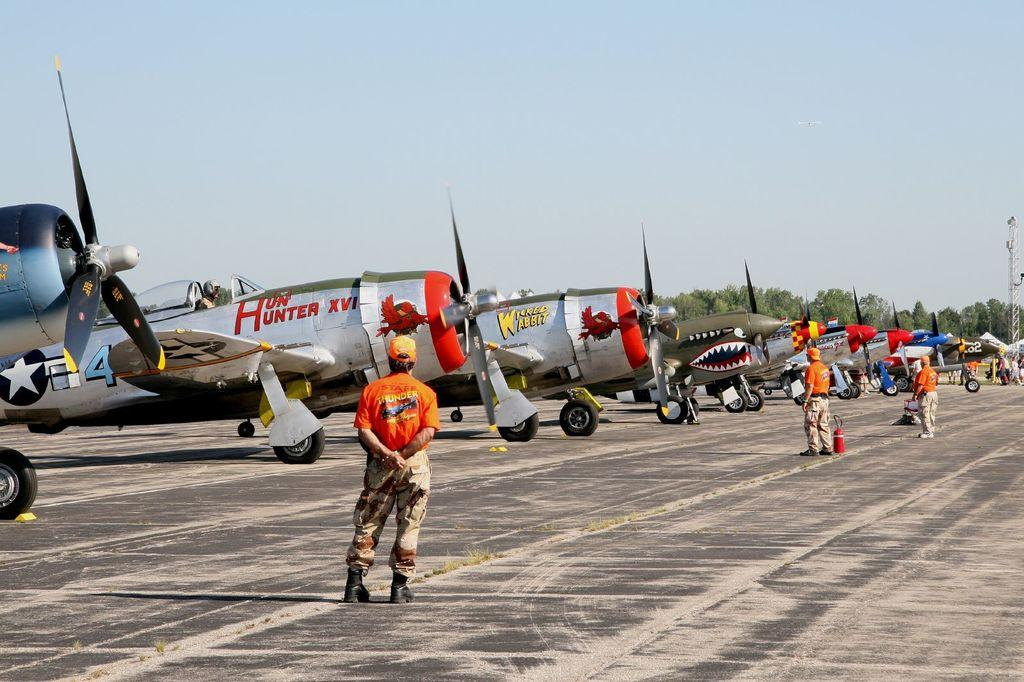<image>
Provide a brief description of the given image. a line of aircraft, one of which has the word Hunter written on the side 